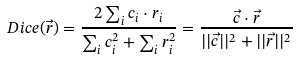<formula> <loc_0><loc_0><loc_500><loc_500>D i c e ( \vec { r } ) = \frac { 2 \sum _ { i } c _ { i } \cdot r _ { i } } { \sum _ { i } c _ { i } ^ { 2 } + \sum _ { i } r _ { i } ^ { 2 } } = \frac { \vec { c } \cdot \vec { r } } { | | \vec { c } | | ^ { 2 } + | | \vec { r } | | ^ { 2 } }</formula> 